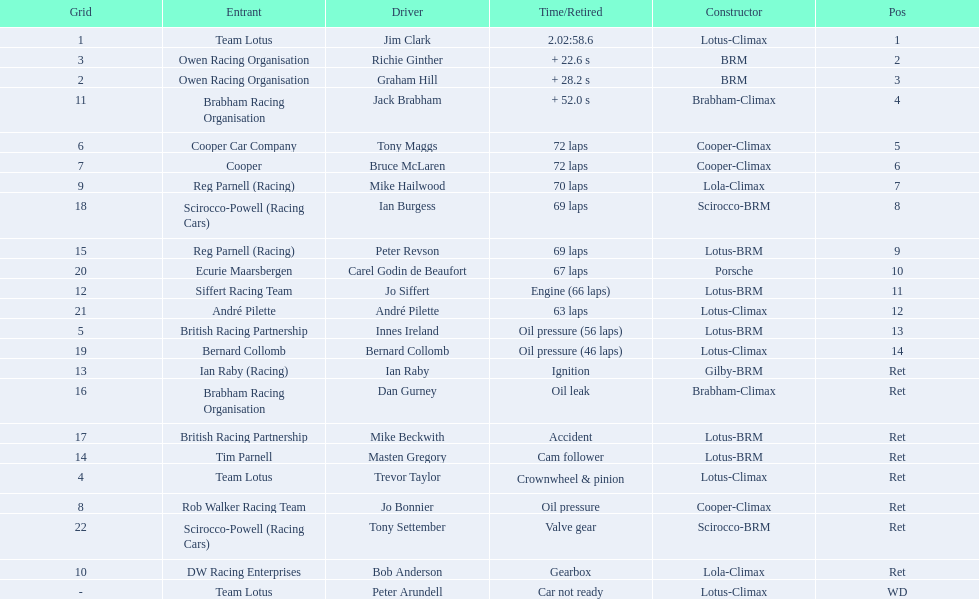Who were the drivers at the 1963 international gold cup? Jim Clark, Richie Ginther, Graham Hill, Jack Brabham, Tony Maggs, Bruce McLaren, Mike Hailwood, Ian Burgess, Peter Revson, Carel Godin de Beaufort, Jo Siffert, André Pilette, Innes Ireland, Bernard Collomb, Ian Raby, Dan Gurney, Mike Beckwith, Masten Gregory, Trevor Taylor, Jo Bonnier, Tony Settember, Bob Anderson, Peter Arundell. What was tony maggs position? 5. What was jo siffert? 11. Who came in earlier? Tony Maggs. 